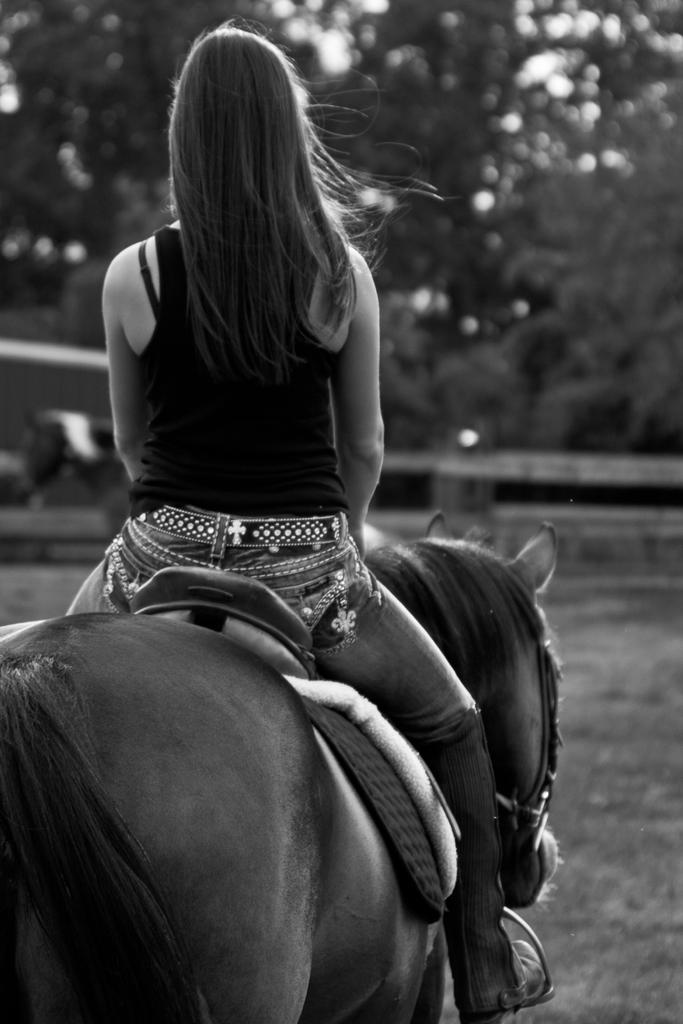What is the color scheme of the image? The image is black and white. Who is present in the image? There is a woman in the image. What is the woman doing in the image? The woman is riding a horse. What is the woman wearing in the image? The woman is wearing a T-shirt and trousers. What can be seen in the background of the image? There are trees in the background of the image. What type of ground is visible in the image? The ground appears to be grass. Where is the faucet located in the image? There is no faucet present in the image. What color are the woman's toes in the image? The image is black and white, so it is not possible to determine the color of the woman's toes. 